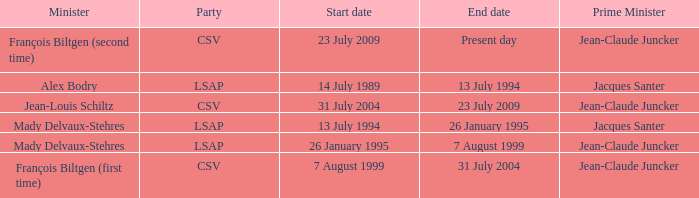Who was the minister for the CSV party with a present day end date? François Biltgen (second time). 